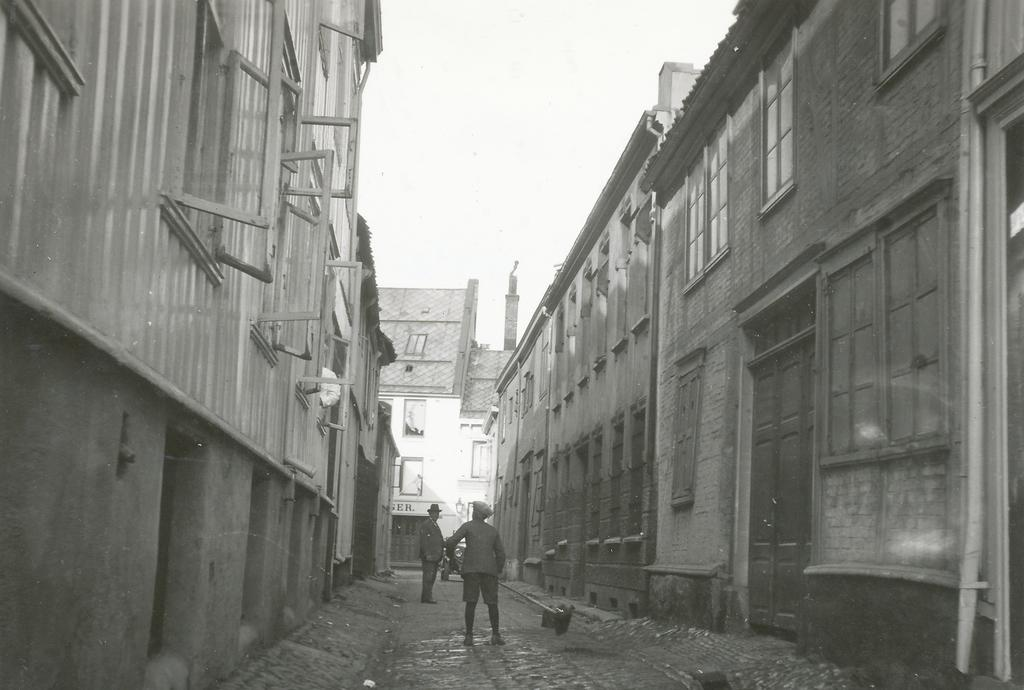How many people are standing on the road in the image? There are two persons standing on the road in the image. What type of structures can be seen in the image? There are buildings in the image. Can you describe a specific feature of one of the buildings? There is a door visible in the image. What else can be seen on the buildings in the image? There are windows in the image. What is visible in the background of the image? The sky is visible in the background of the image. What type of music can be heard playing in the background of the image? There is no music present in the image, as it is a still photograph. 